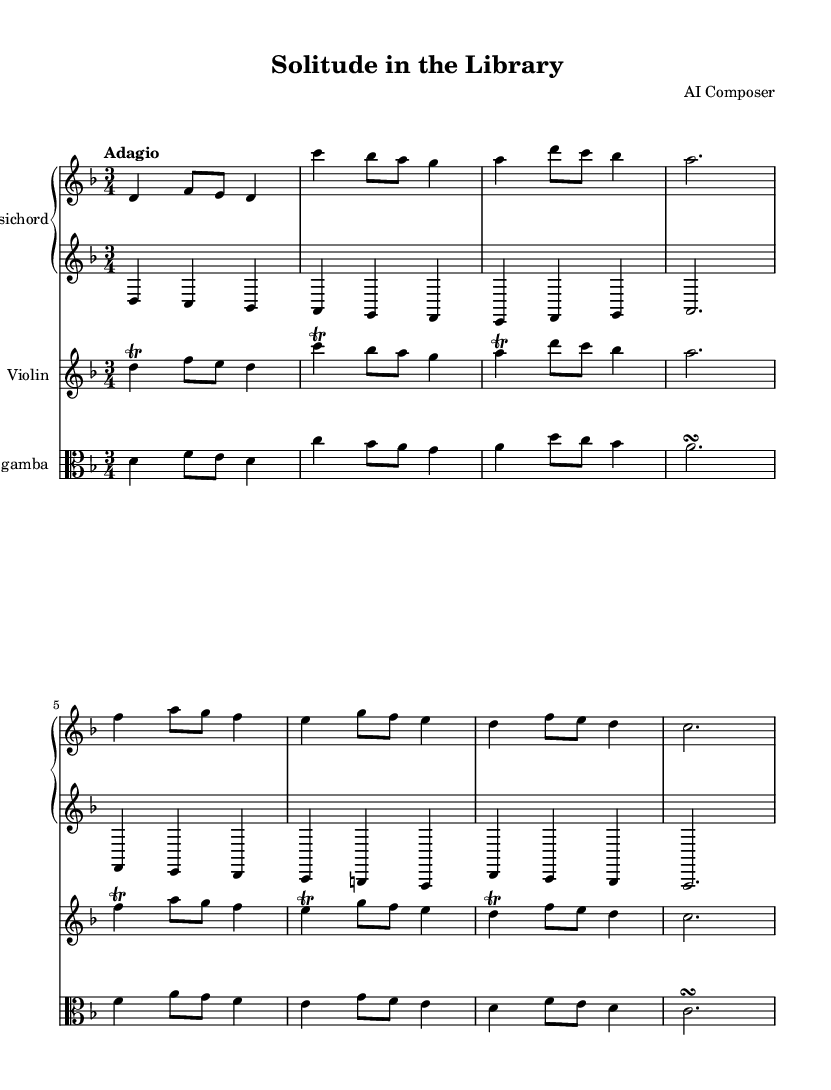What is the key signature of this music? The key signature is indicated by the sharp or flat symbols at the beginning of the staff lines. In this case, there are no accidentals shown, which corresponds to the key of D minor, indicated by the presence of B flat.
Answer: D minor What is the time signature of this music? The time signature is displayed as a fraction at the beginning of the piece. Here, it shows 3/4, meaning there are three beats per measure and a quarter note receives one beat.
Answer: 3/4 What is the tempo marking for this piece? The tempo marking is written directly above the staff and indicates the speed of the piece. In this case, it is marked "Adagio," suggesting a slow tempo.
Answer: Adagio How many measures are in the piece? By counting the individual groups of notes and rests, each separated by bar lines, we can determine that there are a total of 12 measures present in this score.
Answer: 12 Which instruments are featured in this piece? The instruments can be identified by their respective labels on the staves at the beginning of each part. This piece features a Harpsichord, Violin, and Viola da gamba.
Answer: Harpsichord, Violin, Viola da gamba What is the rhythmic pattern of the first measure? The first measure contains notes with specific durations: a dotted quarter note followed by two eighth notes. This combination gives a distinct rhythmic feel for the opening of the piece.
Answer: Dotted quarter, two eighths Which melodic ornament is used in the violin part? The violin part includes a trill, which is indicated with the notation above the note. This ornament signifies that the player should rapidly alternate between the written note and the note one step above it.
Answer: Trill 